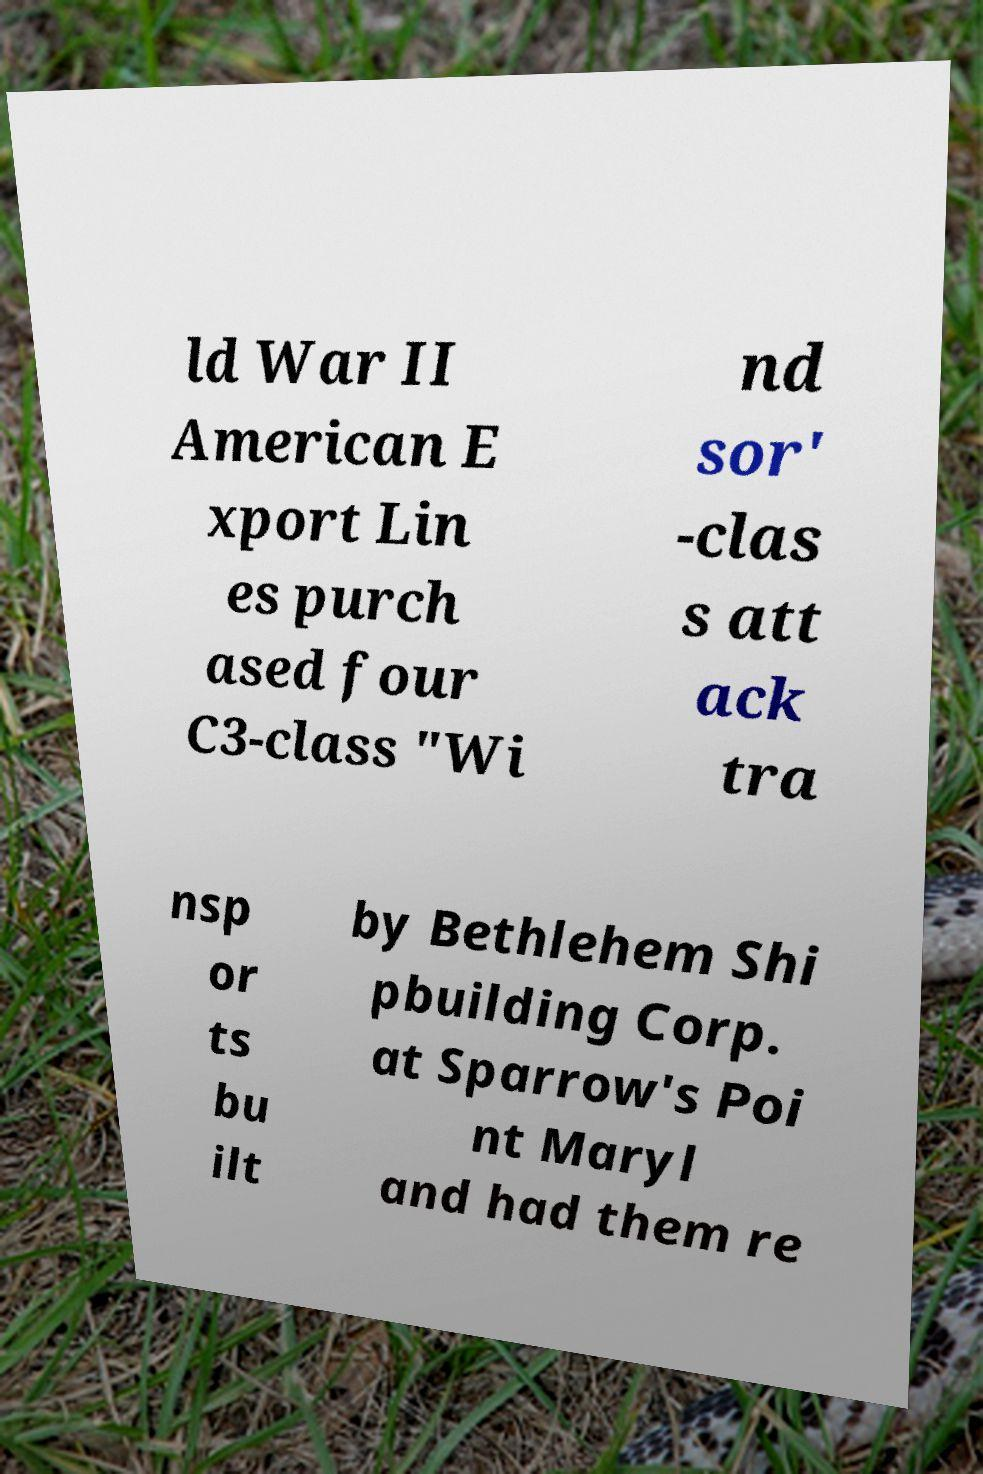Please identify and transcribe the text found in this image. ld War II American E xport Lin es purch ased four C3-class "Wi nd sor' -clas s att ack tra nsp or ts bu ilt by Bethlehem Shi pbuilding Corp. at Sparrow's Poi nt Maryl and had them re 